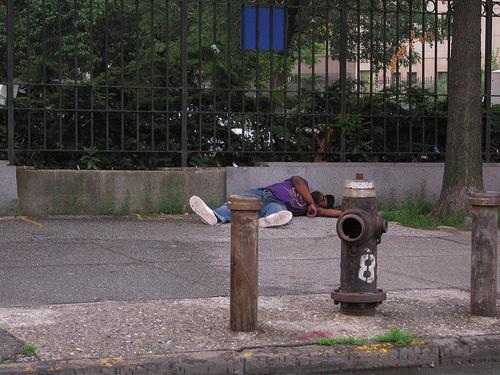Question: where was the picture taken?
Choices:
A. On a street.
B. At the amusement park.
C. From the ferris wheel.
D. From the top.
Answer with the letter. Answer: A Question: what is green?
Choices:
A. Trees.
B. Emeralds.
C. Cactuses.
D. Grass.
Answer with the letter. Answer: A Question: why is a man lying down?
Choices:
A. He is sick.
B. He fell.
C. To sleep.
D. He is unconscious.
Answer with the letter. Answer: C Question: what is purple?
Choices:
A. Man's shirt.
B. A grape.
C. Woman's shoes.
D. Kid's socks.
Answer with the letter. Answer: A Question: who has white shoes?
Choices:
A. Nurse's.
B. Pharmacist's.
C. The man.
D. The waitress.
Answer with the letter. Answer: C Question: what is black and dirty?
Choices:
A. Shoes.
B. Fire hydrant.
C. Pants.
D. Car.
Answer with the letter. Answer: B 